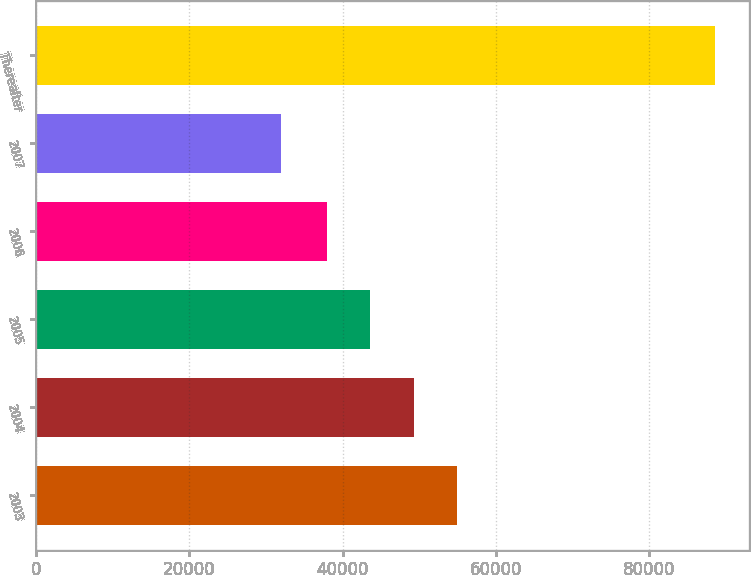Convert chart. <chart><loc_0><loc_0><loc_500><loc_500><bar_chart><fcel>2003<fcel>2004<fcel>2005<fcel>2006<fcel>2007<fcel>Thereafter<nl><fcel>54955.9<fcel>49280.6<fcel>43605.3<fcel>37930<fcel>31902<fcel>88655<nl></chart> 